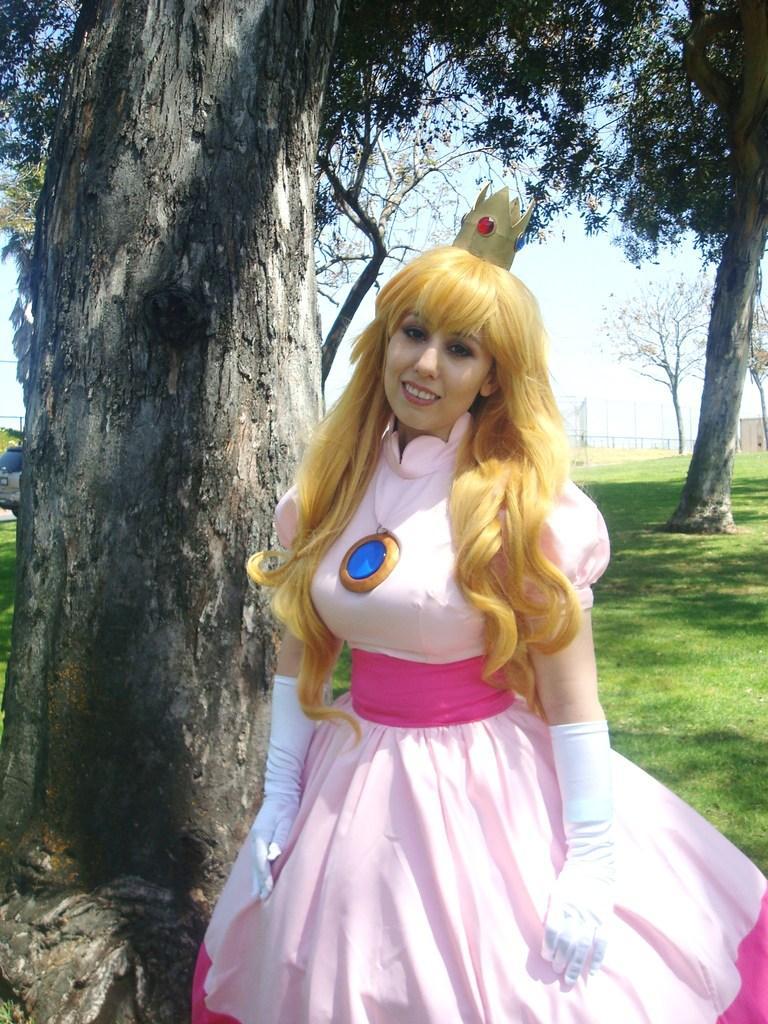Could you give a brief overview of what you see in this image? In the foreground I can see a woman on grass and trees. In the background I can see fencehouses, vehicle on the road and the sky. This image is taken may be in a park. 